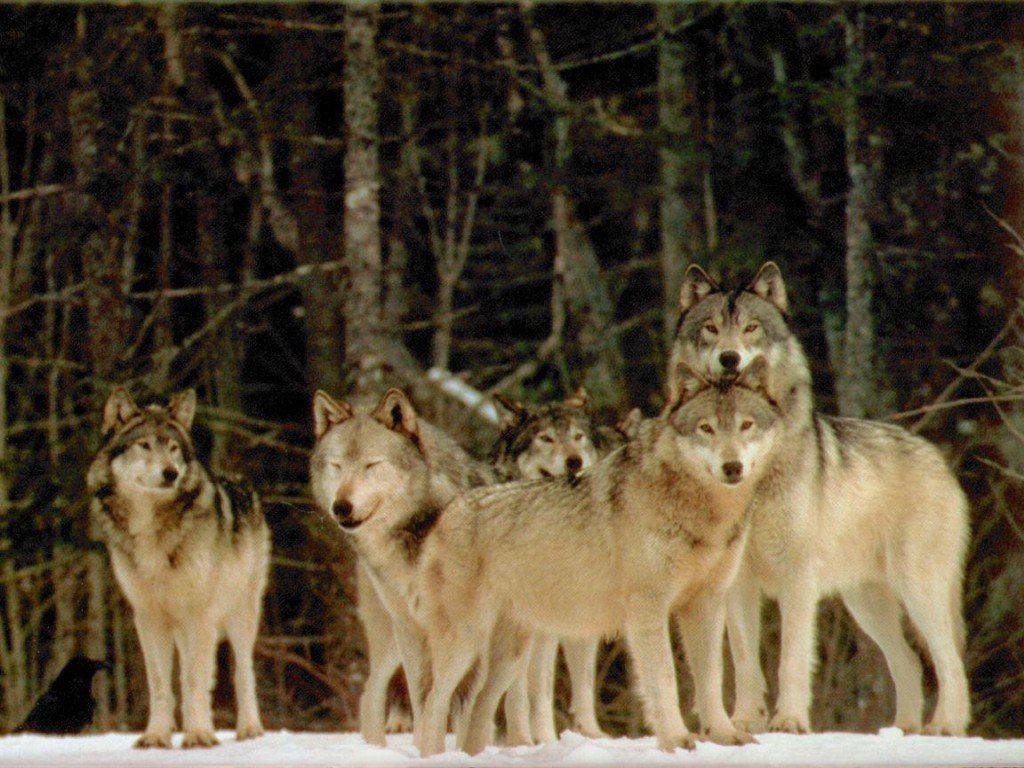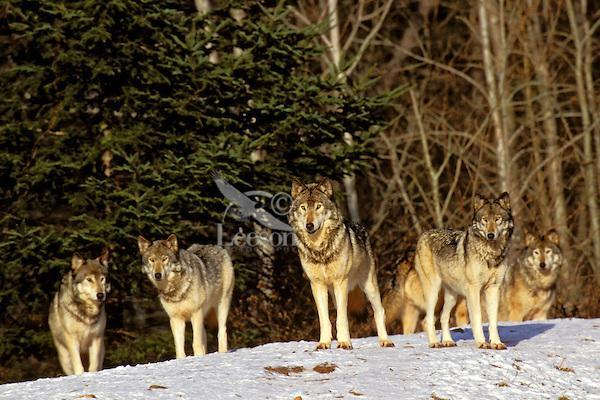The first image is the image on the left, the second image is the image on the right. Given the left and right images, does the statement "The wolves are in the snow in only one of the images." hold true? Answer yes or no. No. 